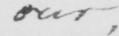What text is written in this handwritten line? our , 